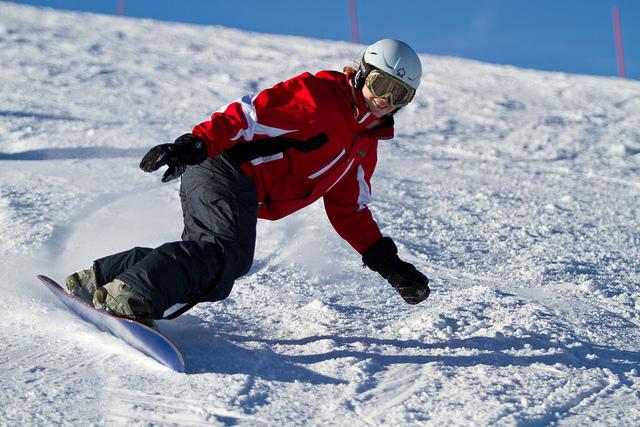Is he snowboarding?
Short answer required. Yes. How many snowboards are there?
Short answer required. 1. Does the person wear gloves?
Keep it brief. Yes. Will this person get hurt?
Answer briefly. No. What is the color of the skate?
Be succinct. Blue. How much snow is on the ground?
Keep it brief. Lot. 